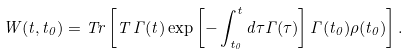Convert formula to latex. <formula><loc_0><loc_0><loc_500><loc_500>W ( t , t _ { 0 } ) = T r \left [ T \, \Gamma ( t ) \exp \left [ - \int _ { t _ { 0 } } ^ { t } d \tau \Gamma ( \tau ) \right ] \Gamma ( t _ { 0 } ) \rho ( t _ { 0 } ) \right ] .</formula> 